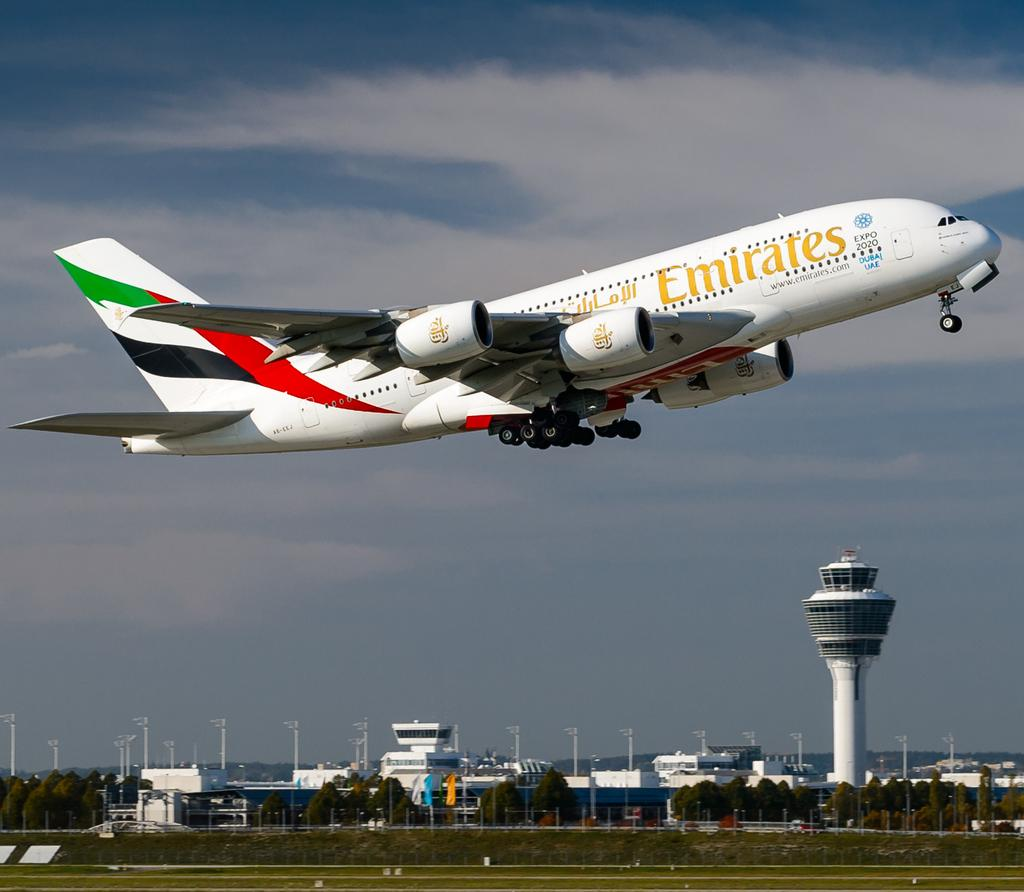<image>
Create a compact narrative representing the image presented. An Emirates plane is taking off of the ground. 